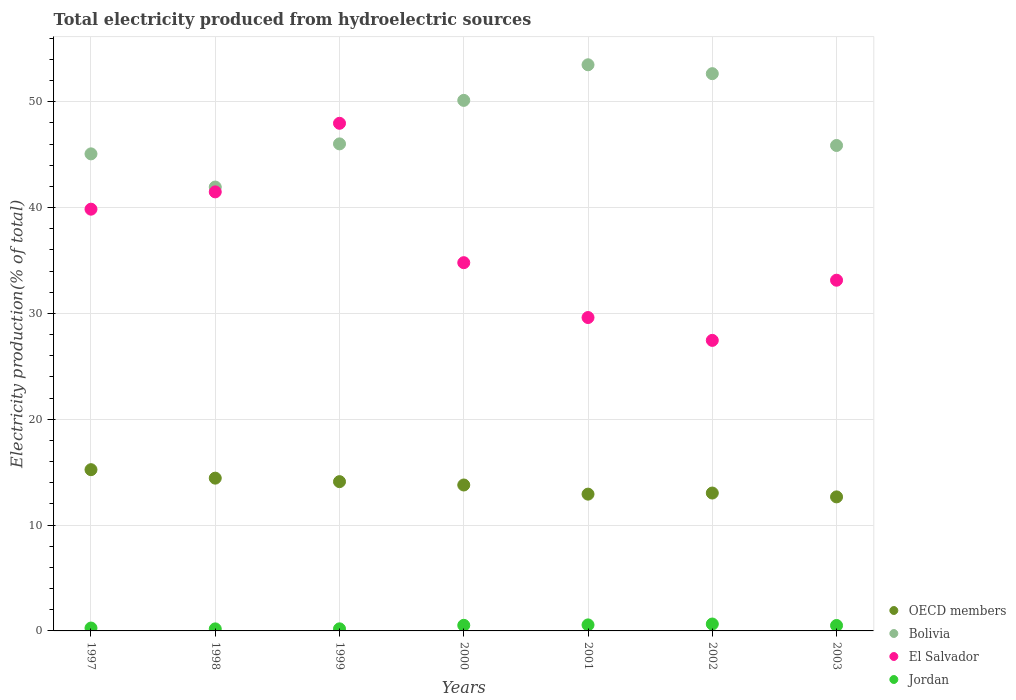Is the number of dotlines equal to the number of legend labels?
Your answer should be compact. Yes. What is the total electricity produced in OECD members in 2001?
Offer a very short reply. 12.92. Across all years, what is the maximum total electricity produced in Jordan?
Provide a short and direct response. 0.65. Across all years, what is the minimum total electricity produced in Jordan?
Keep it short and to the point. 0.19. In which year was the total electricity produced in Jordan maximum?
Keep it short and to the point. 2002. In which year was the total electricity produced in Jordan minimum?
Provide a short and direct response. 1998. What is the total total electricity produced in Bolivia in the graph?
Your answer should be very brief. 335.18. What is the difference between the total electricity produced in OECD members in 2000 and that in 2002?
Offer a terse response. 0.76. What is the difference between the total electricity produced in Jordan in 2003 and the total electricity produced in Bolivia in 2000?
Your response must be concise. -49.62. What is the average total electricity produced in Jordan per year?
Offer a very short reply. 0.42. In the year 1999, what is the difference between the total electricity produced in Jordan and total electricity produced in OECD members?
Keep it short and to the point. -13.91. What is the ratio of the total electricity produced in Jordan in 2001 to that in 2003?
Your response must be concise. 1.11. What is the difference between the highest and the second highest total electricity produced in OECD members?
Provide a short and direct response. 0.8. What is the difference between the highest and the lowest total electricity produced in Jordan?
Keep it short and to the point. 0.46. In how many years, is the total electricity produced in OECD members greater than the average total electricity produced in OECD members taken over all years?
Offer a very short reply. 4. Is the sum of the total electricity produced in Jordan in 1999 and 2001 greater than the maximum total electricity produced in Bolivia across all years?
Your answer should be very brief. No. Is it the case that in every year, the sum of the total electricity produced in Bolivia and total electricity produced in Jordan  is greater than the sum of total electricity produced in El Salvador and total electricity produced in OECD members?
Your answer should be compact. Yes. Does the total electricity produced in El Salvador monotonically increase over the years?
Make the answer very short. No. Is the total electricity produced in Bolivia strictly less than the total electricity produced in El Salvador over the years?
Provide a short and direct response. No. How many dotlines are there?
Your answer should be compact. 4. What is the difference between two consecutive major ticks on the Y-axis?
Keep it short and to the point. 10. Are the values on the major ticks of Y-axis written in scientific E-notation?
Provide a short and direct response. No. Does the graph contain any zero values?
Ensure brevity in your answer.  No. Where does the legend appear in the graph?
Make the answer very short. Bottom right. How many legend labels are there?
Offer a terse response. 4. How are the legend labels stacked?
Your answer should be very brief. Vertical. What is the title of the graph?
Your response must be concise. Total electricity produced from hydroelectric sources. Does "Palau" appear as one of the legend labels in the graph?
Provide a succinct answer. No. What is the label or title of the X-axis?
Give a very brief answer. Years. What is the label or title of the Y-axis?
Keep it short and to the point. Electricity production(% of total). What is the Electricity production(% of total) of OECD members in 1997?
Give a very brief answer. 15.24. What is the Electricity production(% of total) of Bolivia in 1997?
Give a very brief answer. 45.07. What is the Electricity production(% of total) in El Salvador in 1997?
Your response must be concise. 39.85. What is the Electricity production(% of total) in Jordan in 1997?
Your answer should be compact. 0.27. What is the Electricity production(% of total) in OECD members in 1998?
Offer a terse response. 14.44. What is the Electricity production(% of total) in Bolivia in 1998?
Offer a terse response. 41.94. What is the Electricity production(% of total) in El Salvador in 1998?
Ensure brevity in your answer.  41.48. What is the Electricity production(% of total) of Jordan in 1998?
Your answer should be compact. 0.19. What is the Electricity production(% of total) of OECD members in 1999?
Ensure brevity in your answer.  14.1. What is the Electricity production(% of total) of Bolivia in 1999?
Ensure brevity in your answer.  46.02. What is the Electricity production(% of total) of El Salvador in 1999?
Offer a very short reply. 47.96. What is the Electricity production(% of total) of Jordan in 1999?
Your answer should be compact. 0.2. What is the Electricity production(% of total) of OECD members in 2000?
Offer a very short reply. 13.79. What is the Electricity production(% of total) in Bolivia in 2000?
Provide a short and direct response. 50.13. What is the Electricity production(% of total) of El Salvador in 2000?
Offer a very short reply. 34.79. What is the Electricity production(% of total) of Jordan in 2000?
Keep it short and to the point. 0.53. What is the Electricity production(% of total) of OECD members in 2001?
Keep it short and to the point. 12.92. What is the Electricity production(% of total) in Bolivia in 2001?
Your answer should be compact. 53.49. What is the Electricity production(% of total) of El Salvador in 2001?
Provide a short and direct response. 29.61. What is the Electricity production(% of total) of Jordan in 2001?
Provide a succinct answer. 0.57. What is the Electricity production(% of total) of OECD members in 2002?
Ensure brevity in your answer.  13.03. What is the Electricity production(% of total) in Bolivia in 2002?
Provide a succinct answer. 52.65. What is the Electricity production(% of total) of El Salvador in 2002?
Your answer should be very brief. 27.45. What is the Electricity production(% of total) of Jordan in 2002?
Ensure brevity in your answer.  0.65. What is the Electricity production(% of total) of OECD members in 2003?
Your response must be concise. 12.66. What is the Electricity production(% of total) of Bolivia in 2003?
Ensure brevity in your answer.  45.87. What is the Electricity production(% of total) of El Salvador in 2003?
Keep it short and to the point. 33.14. What is the Electricity production(% of total) of Jordan in 2003?
Provide a short and direct response. 0.51. Across all years, what is the maximum Electricity production(% of total) in OECD members?
Make the answer very short. 15.24. Across all years, what is the maximum Electricity production(% of total) in Bolivia?
Give a very brief answer. 53.49. Across all years, what is the maximum Electricity production(% of total) in El Salvador?
Offer a terse response. 47.96. Across all years, what is the maximum Electricity production(% of total) of Jordan?
Give a very brief answer. 0.65. Across all years, what is the minimum Electricity production(% of total) in OECD members?
Provide a short and direct response. 12.66. Across all years, what is the minimum Electricity production(% of total) of Bolivia?
Your response must be concise. 41.94. Across all years, what is the minimum Electricity production(% of total) in El Salvador?
Your answer should be compact. 27.45. Across all years, what is the minimum Electricity production(% of total) in Jordan?
Offer a terse response. 0.19. What is the total Electricity production(% of total) of OECD members in the graph?
Provide a short and direct response. 96.18. What is the total Electricity production(% of total) of Bolivia in the graph?
Give a very brief answer. 335.18. What is the total Electricity production(% of total) of El Salvador in the graph?
Give a very brief answer. 254.29. What is the total Electricity production(% of total) of Jordan in the graph?
Offer a terse response. 2.92. What is the difference between the Electricity production(% of total) of OECD members in 1997 and that in 1998?
Your answer should be compact. 0.8. What is the difference between the Electricity production(% of total) of Bolivia in 1997 and that in 1998?
Your answer should be very brief. 3.13. What is the difference between the Electricity production(% of total) of El Salvador in 1997 and that in 1998?
Your response must be concise. -1.63. What is the difference between the Electricity production(% of total) in Jordan in 1997 and that in 1998?
Provide a succinct answer. 0.08. What is the difference between the Electricity production(% of total) of OECD members in 1997 and that in 1999?
Provide a succinct answer. 1.13. What is the difference between the Electricity production(% of total) in Bolivia in 1997 and that in 1999?
Your answer should be compact. -0.94. What is the difference between the Electricity production(% of total) of El Salvador in 1997 and that in 1999?
Provide a short and direct response. -8.11. What is the difference between the Electricity production(% of total) in Jordan in 1997 and that in 1999?
Give a very brief answer. 0.07. What is the difference between the Electricity production(% of total) of OECD members in 1997 and that in 2000?
Your answer should be very brief. 1.45. What is the difference between the Electricity production(% of total) in Bolivia in 1997 and that in 2000?
Provide a succinct answer. -5.05. What is the difference between the Electricity production(% of total) of El Salvador in 1997 and that in 2000?
Make the answer very short. 5.06. What is the difference between the Electricity production(% of total) in Jordan in 1997 and that in 2000?
Offer a terse response. -0.26. What is the difference between the Electricity production(% of total) in OECD members in 1997 and that in 2001?
Your answer should be compact. 2.31. What is the difference between the Electricity production(% of total) in Bolivia in 1997 and that in 2001?
Your answer should be compact. -8.42. What is the difference between the Electricity production(% of total) of El Salvador in 1997 and that in 2001?
Ensure brevity in your answer.  10.24. What is the difference between the Electricity production(% of total) in Jordan in 1997 and that in 2001?
Provide a short and direct response. -0.3. What is the difference between the Electricity production(% of total) of OECD members in 1997 and that in 2002?
Ensure brevity in your answer.  2.21. What is the difference between the Electricity production(% of total) in Bolivia in 1997 and that in 2002?
Make the answer very short. -7.58. What is the difference between the Electricity production(% of total) of El Salvador in 1997 and that in 2002?
Provide a short and direct response. 12.4. What is the difference between the Electricity production(% of total) of Jordan in 1997 and that in 2002?
Keep it short and to the point. -0.38. What is the difference between the Electricity production(% of total) of OECD members in 1997 and that in 2003?
Offer a very short reply. 2.57. What is the difference between the Electricity production(% of total) in Bolivia in 1997 and that in 2003?
Your answer should be very brief. -0.79. What is the difference between the Electricity production(% of total) of El Salvador in 1997 and that in 2003?
Provide a short and direct response. 6.71. What is the difference between the Electricity production(% of total) in Jordan in 1997 and that in 2003?
Your answer should be very brief. -0.24. What is the difference between the Electricity production(% of total) in OECD members in 1998 and that in 1999?
Your response must be concise. 0.33. What is the difference between the Electricity production(% of total) of Bolivia in 1998 and that in 1999?
Provide a short and direct response. -4.08. What is the difference between the Electricity production(% of total) of El Salvador in 1998 and that in 1999?
Provide a succinct answer. -6.48. What is the difference between the Electricity production(% of total) in Jordan in 1998 and that in 1999?
Offer a very short reply. -0.01. What is the difference between the Electricity production(% of total) of OECD members in 1998 and that in 2000?
Your answer should be very brief. 0.65. What is the difference between the Electricity production(% of total) of Bolivia in 1998 and that in 2000?
Your answer should be compact. -8.19. What is the difference between the Electricity production(% of total) in El Salvador in 1998 and that in 2000?
Your answer should be very brief. 6.69. What is the difference between the Electricity production(% of total) of Jordan in 1998 and that in 2000?
Your answer should be very brief. -0.34. What is the difference between the Electricity production(% of total) in OECD members in 1998 and that in 2001?
Ensure brevity in your answer.  1.51. What is the difference between the Electricity production(% of total) in Bolivia in 1998 and that in 2001?
Your answer should be compact. -11.55. What is the difference between the Electricity production(% of total) in El Salvador in 1998 and that in 2001?
Keep it short and to the point. 11.87. What is the difference between the Electricity production(% of total) in Jordan in 1998 and that in 2001?
Provide a short and direct response. -0.38. What is the difference between the Electricity production(% of total) of OECD members in 1998 and that in 2002?
Provide a succinct answer. 1.41. What is the difference between the Electricity production(% of total) of Bolivia in 1998 and that in 2002?
Your response must be concise. -10.71. What is the difference between the Electricity production(% of total) of El Salvador in 1998 and that in 2002?
Ensure brevity in your answer.  14.03. What is the difference between the Electricity production(% of total) in Jordan in 1998 and that in 2002?
Provide a succinct answer. -0.46. What is the difference between the Electricity production(% of total) of OECD members in 1998 and that in 2003?
Provide a succinct answer. 1.77. What is the difference between the Electricity production(% of total) in Bolivia in 1998 and that in 2003?
Give a very brief answer. -3.93. What is the difference between the Electricity production(% of total) of El Salvador in 1998 and that in 2003?
Your answer should be very brief. 8.35. What is the difference between the Electricity production(% of total) of Jordan in 1998 and that in 2003?
Ensure brevity in your answer.  -0.32. What is the difference between the Electricity production(% of total) of OECD members in 1999 and that in 2000?
Offer a very short reply. 0.32. What is the difference between the Electricity production(% of total) of Bolivia in 1999 and that in 2000?
Offer a terse response. -4.11. What is the difference between the Electricity production(% of total) of El Salvador in 1999 and that in 2000?
Provide a succinct answer. 13.17. What is the difference between the Electricity production(% of total) of Jordan in 1999 and that in 2000?
Make the answer very short. -0.33. What is the difference between the Electricity production(% of total) of OECD members in 1999 and that in 2001?
Your response must be concise. 1.18. What is the difference between the Electricity production(% of total) of Bolivia in 1999 and that in 2001?
Offer a very short reply. -7.47. What is the difference between the Electricity production(% of total) in El Salvador in 1999 and that in 2001?
Your response must be concise. 18.35. What is the difference between the Electricity production(% of total) in Jordan in 1999 and that in 2001?
Provide a succinct answer. -0.37. What is the difference between the Electricity production(% of total) in OECD members in 1999 and that in 2002?
Provide a short and direct response. 1.08. What is the difference between the Electricity production(% of total) in Bolivia in 1999 and that in 2002?
Offer a very short reply. -6.63. What is the difference between the Electricity production(% of total) in El Salvador in 1999 and that in 2002?
Offer a terse response. 20.51. What is the difference between the Electricity production(% of total) in Jordan in 1999 and that in 2002?
Your answer should be very brief. -0.45. What is the difference between the Electricity production(% of total) in OECD members in 1999 and that in 2003?
Your response must be concise. 1.44. What is the difference between the Electricity production(% of total) in Bolivia in 1999 and that in 2003?
Offer a terse response. 0.15. What is the difference between the Electricity production(% of total) in El Salvador in 1999 and that in 2003?
Provide a succinct answer. 14.83. What is the difference between the Electricity production(% of total) in Jordan in 1999 and that in 2003?
Keep it short and to the point. -0.32. What is the difference between the Electricity production(% of total) of OECD members in 2000 and that in 2001?
Ensure brevity in your answer.  0.86. What is the difference between the Electricity production(% of total) in Bolivia in 2000 and that in 2001?
Offer a terse response. -3.36. What is the difference between the Electricity production(% of total) of El Salvador in 2000 and that in 2001?
Your answer should be very brief. 5.18. What is the difference between the Electricity production(% of total) in Jordan in 2000 and that in 2001?
Provide a short and direct response. -0.04. What is the difference between the Electricity production(% of total) in OECD members in 2000 and that in 2002?
Keep it short and to the point. 0.76. What is the difference between the Electricity production(% of total) of Bolivia in 2000 and that in 2002?
Make the answer very short. -2.52. What is the difference between the Electricity production(% of total) of El Salvador in 2000 and that in 2002?
Your answer should be very brief. 7.34. What is the difference between the Electricity production(% of total) in Jordan in 2000 and that in 2002?
Offer a very short reply. -0.12. What is the difference between the Electricity production(% of total) in OECD members in 2000 and that in 2003?
Keep it short and to the point. 1.12. What is the difference between the Electricity production(% of total) in Bolivia in 2000 and that in 2003?
Your answer should be very brief. 4.26. What is the difference between the Electricity production(% of total) of El Salvador in 2000 and that in 2003?
Ensure brevity in your answer.  1.66. What is the difference between the Electricity production(% of total) in Jordan in 2000 and that in 2003?
Your answer should be compact. 0.02. What is the difference between the Electricity production(% of total) of OECD members in 2001 and that in 2002?
Offer a very short reply. -0.1. What is the difference between the Electricity production(% of total) in Bolivia in 2001 and that in 2002?
Keep it short and to the point. 0.84. What is the difference between the Electricity production(% of total) of El Salvador in 2001 and that in 2002?
Make the answer very short. 2.16. What is the difference between the Electricity production(% of total) of Jordan in 2001 and that in 2002?
Provide a succinct answer. -0.08. What is the difference between the Electricity production(% of total) of OECD members in 2001 and that in 2003?
Offer a very short reply. 0.26. What is the difference between the Electricity production(% of total) of Bolivia in 2001 and that in 2003?
Your answer should be very brief. 7.62. What is the difference between the Electricity production(% of total) of El Salvador in 2001 and that in 2003?
Keep it short and to the point. -3.53. What is the difference between the Electricity production(% of total) of Jordan in 2001 and that in 2003?
Offer a very short reply. 0.06. What is the difference between the Electricity production(% of total) of OECD members in 2002 and that in 2003?
Your answer should be very brief. 0.36. What is the difference between the Electricity production(% of total) of Bolivia in 2002 and that in 2003?
Provide a succinct answer. 6.79. What is the difference between the Electricity production(% of total) in El Salvador in 2002 and that in 2003?
Your response must be concise. -5.68. What is the difference between the Electricity production(% of total) in Jordan in 2002 and that in 2003?
Your answer should be compact. 0.14. What is the difference between the Electricity production(% of total) of OECD members in 1997 and the Electricity production(% of total) of Bolivia in 1998?
Ensure brevity in your answer.  -26.7. What is the difference between the Electricity production(% of total) of OECD members in 1997 and the Electricity production(% of total) of El Salvador in 1998?
Ensure brevity in your answer.  -26.25. What is the difference between the Electricity production(% of total) of OECD members in 1997 and the Electricity production(% of total) of Jordan in 1998?
Offer a very short reply. 15.04. What is the difference between the Electricity production(% of total) of Bolivia in 1997 and the Electricity production(% of total) of El Salvador in 1998?
Give a very brief answer. 3.59. What is the difference between the Electricity production(% of total) in Bolivia in 1997 and the Electricity production(% of total) in Jordan in 1998?
Your answer should be very brief. 44.88. What is the difference between the Electricity production(% of total) in El Salvador in 1997 and the Electricity production(% of total) in Jordan in 1998?
Your answer should be compact. 39.66. What is the difference between the Electricity production(% of total) of OECD members in 1997 and the Electricity production(% of total) of Bolivia in 1999?
Provide a short and direct response. -30.78. What is the difference between the Electricity production(% of total) of OECD members in 1997 and the Electricity production(% of total) of El Salvador in 1999?
Your answer should be very brief. -32.73. What is the difference between the Electricity production(% of total) of OECD members in 1997 and the Electricity production(% of total) of Jordan in 1999?
Keep it short and to the point. 15.04. What is the difference between the Electricity production(% of total) in Bolivia in 1997 and the Electricity production(% of total) in El Salvador in 1999?
Provide a succinct answer. -2.89. What is the difference between the Electricity production(% of total) in Bolivia in 1997 and the Electricity production(% of total) in Jordan in 1999?
Ensure brevity in your answer.  44.88. What is the difference between the Electricity production(% of total) in El Salvador in 1997 and the Electricity production(% of total) in Jordan in 1999?
Ensure brevity in your answer.  39.65. What is the difference between the Electricity production(% of total) of OECD members in 1997 and the Electricity production(% of total) of Bolivia in 2000?
Ensure brevity in your answer.  -34.89. What is the difference between the Electricity production(% of total) in OECD members in 1997 and the Electricity production(% of total) in El Salvador in 2000?
Your response must be concise. -19.56. What is the difference between the Electricity production(% of total) in OECD members in 1997 and the Electricity production(% of total) in Jordan in 2000?
Offer a terse response. 14.71. What is the difference between the Electricity production(% of total) in Bolivia in 1997 and the Electricity production(% of total) in El Salvador in 2000?
Provide a succinct answer. 10.28. What is the difference between the Electricity production(% of total) in Bolivia in 1997 and the Electricity production(% of total) in Jordan in 2000?
Offer a terse response. 44.55. What is the difference between the Electricity production(% of total) of El Salvador in 1997 and the Electricity production(% of total) of Jordan in 2000?
Your answer should be compact. 39.32. What is the difference between the Electricity production(% of total) in OECD members in 1997 and the Electricity production(% of total) in Bolivia in 2001?
Offer a very short reply. -38.26. What is the difference between the Electricity production(% of total) in OECD members in 1997 and the Electricity production(% of total) in El Salvador in 2001?
Offer a terse response. -14.38. What is the difference between the Electricity production(% of total) of OECD members in 1997 and the Electricity production(% of total) of Jordan in 2001?
Offer a terse response. 14.67. What is the difference between the Electricity production(% of total) in Bolivia in 1997 and the Electricity production(% of total) in El Salvador in 2001?
Your answer should be compact. 15.46. What is the difference between the Electricity production(% of total) in Bolivia in 1997 and the Electricity production(% of total) in Jordan in 2001?
Provide a succinct answer. 44.51. What is the difference between the Electricity production(% of total) in El Salvador in 1997 and the Electricity production(% of total) in Jordan in 2001?
Your answer should be very brief. 39.28. What is the difference between the Electricity production(% of total) in OECD members in 1997 and the Electricity production(% of total) in Bolivia in 2002?
Offer a terse response. -37.42. What is the difference between the Electricity production(% of total) of OECD members in 1997 and the Electricity production(% of total) of El Salvador in 2002?
Provide a succinct answer. -12.22. What is the difference between the Electricity production(% of total) in OECD members in 1997 and the Electricity production(% of total) in Jordan in 2002?
Keep it short and to the point. 14.58. What is the difference between the Electricity production(% of total) in Bolivia in 1997 and the Electricity production(% of total) in El Salvador in 2002?
Ensure brevity in your answer.  17.62. What is the difference between the Electricity production(% of total) in Bolivia in 1997 and the Electricity production(% of total) in Jordan in 2002?
Offer a very short reply. 44.42. What is the difference between the Electricity production(% of total) in El Salvador in 1997 and the Electricity production(% of total) in Jordan in 2002?
Your answer should be very brief. 39.2. What is the difference between the Electricity production(% of total) in OECD members in 1997 and the Electricity production(% of total) in Bolivia in 2003?
Provide a succinct answer. -30.63. What is the difference between the Electricity production(% of total) of OECD members in 1997 and the Electricity production(% of total) of El Salvador in 2003?
Your answer should be very brief. -17.9. What is the difference between the Electricity production(% of total) in OECD members in 1997 and the Electricity production(% of total) in Jordan in 2003?
Give a very brief answer. 14.72. What is the difference between the Electricity production(% of total) in Bolivia in 1997 and the Electricity production(% of total) in El Salvador in 2003?
Provide a short and direct response. 11.94. What is the difference between the Electricity production(% of total) of Bolivia in 1997 and the Electricity production(% of total) of Jordan in 2003?
Give a very brief answer. 44.56. What is the difference between the Electricity production(% of total) in El Salvador in 1997 and the Electricity production(% of total) in Jordan in 2003?
Provide a short and direct response. 39.34. What is the difference between the Electricity production(% of total) of OECD members in 1998 and the Electricity production(% of total) of Bolivia in 1999?
Your response must be concise. -31.58. What is the difference between the Electricity production(% of total) in OECD members in 1998 and the Electricity production(% of total) in El Salvador in 1999?
Provide a short and direct response. -33.53. What is the difference between the Electricity production(% of total) of OECD members in 1998 and the Electricity production(% of total) of Jordan in 1999?
Offer a very short reply. 14.24. What is the difference between the Electricity production(% of total) of Bolivia in 1998 and the Electricity production(% of total) of El Salvador in 1999?
Provide a succinct answer. -6.02. What is the difference between the Electricity production(% of total) of Bolivia in 1998 and the Electricity production(% of total) of Jordan in 1999?
Provide a short and direct response. 41.74. What is the difference between the Electricity production(% of total) of El Salvador in 1998 and the Electricity production(% of total) of Jordan in 1999?
Provide a succinct answer. 41.29. What is the difference between the Electricity production(% of total) in OECD members in 1998 and the Electricity production(% of total) in Bolivia in 2000?
Offer a very short reply. -35.69. What is the difference between the Electricity production(% of total) in OECD members in 1998 and the Electricity production(% of total) in El Salvador in 2000?
Offer a terse response. -20.36. What is the difference between the Electricity production(% of total) of OECD members in 1998 and the Electricity production(% of total) of Jordan in 2000?
Your answer should be compact. 13.91. What is the difference between the Electricity production(% of total) of Bolivia in 1998 and the Electricity production(% of total) of El Salvador in 2000?
Offer a very short reply. 7.15. What is the difference between the Electricity production(% of total) of Bolivia in 1998 and the Electricity production(% of total) of Jordan in 2000?
Keep it short and to the point. 41.41. What is the difference between the Electricity production(% of total) of El Salvador in 1998 and the Electricity production(% of total) of Jordan in 2000?
Provide a short and direct response. 40.95. What is the difference between the Electricity production(% of total) in OECD members in 1998 and the Electricity production(% of total) in Bolivia in 2001?
Give a very brief answer. -39.06. What is the difference between the Electricity production(% of total) in OECD members in 1998 and the Electricity production(% of total) in El Salvador in 2001?
Offer a very short reply. -15.18. What is the difference between the Electricity production(% of total) in OECD members in 1998 and the Electricity production(% of total) in Jordan in 2001?
Your response must be concise. 13.87. What is the difference between the Electricity production(% of total) of Bolivia in 1998 and the Electricity production(% of total) of El Salvador in 2001?
Provide a succinct answer. 12.33. What is the difference between the Electricity production(% of total) of Bolivia in 1998 and the Electricity production(% of total) of Jordan in 2001?
Provide a succinct answer. 41.37. What is the difference between the Electricity production(% of total) of El Salvador in 1998 and the Electricity production(% of total) of Jordan in 2001?
Provide a short and direct response. 40.91. What is the difference between the Electricity production(% of total) in OECD members in 1998 and the Electricity production(% of total) in Bolivia in 2002?
Ensure brevity in your answer.  -38.22. What is the difference between the Electricity production(% of total) in OECD members in 1998 and the Electricity production(% of total) in El Salvador in 2002?
Your response must be concise. -13.02. What is the difference between the Electricity production(% of total) in OECD members in 1998 and the Electricity production(% of total) in Jordan in 2002?
Offer a very short reply. 13.78. What is the difference between the Electricity production(% of total) in Bolivia in 1998 and the Electricity production(% of total) in El Salvador in 2002?
Offer a terse response. 14.49. What is the difference between the Electricity production(% of total) of Bolivia in 1998 and the Electricity production(% of total) of Jordan in 2002?
Offer a very short reply. 41.29. What is the difference between the Electricity production(% of total) in El Salvador in 1998 and the Electricity production(% of total) in Jordan in 2002?
Offer a very short reply. 40.83. What is the difference between the Electricity production(% of total) in OECD members in 1998 and the Electricity production(% of total) in Bolivia in 2003?
Your answer should be compact. -31.43. What is the difference between the Electricity production(% of total) in OECD members in 1998 and the Electricity production(% of total) in El Salvador in 2003?
Offer a terse response. -18.7. What is the difference between the Electricity production(% of total) in OECD members in 1998 and the Electricity production(% of total) in Jordan in 2003?
Ensure brevity in your answer.  13.92. What is the difference between the Electricity production(% of total) of Bolivia in 1998 and the Electricity production(% of total) of El Salvador in 2003?
Offer a terse response. 8.8. What is the difference between the Electricity production(% of total) of Bolivia in 1998 and the Electricity production(% of total) of Jordan in 2003?
Offer a terse response. 41.43. What is the difference between the Electricity production(% of total) in El Salvador in 1998 and the Electricity production(% of total) in Jordan in 2003?
Offer a very short reply. 40.97. What is the difference between the Electricity production(% of total) in OECD members in 1999 and the Electricity production(% of total) in Bolivia in 2000?
Your response must be concise. -36.02. What is the difference between the Electricity production(% of total) of OECD members in 1999 and the Electricity production(% of total) of El Salvador in 2000?
Make the answer very short. -20.69. What is the difference between the Electricity production(% of total) of OECD members in 1999 and the Electricity production(% of total) of Jordan in 2000?
Your response must be concise. 13.58. What is the difference between the Electricity production(% of total) of Bolivia in 1999 and the Electricity production(% of total) of El Salvador in 2000?
Offer a very short reply. 11.22. What is the difference between the Electricity production(% of total) of Bolivia in 1999 and the Electricity production(% of total) of Jordan in 2000?
Ensure brevity in your answer.  45.49. What is the difference between the Electricity production(% of total) in El Salvador in 1999 and the Electricity production(% of total) in Jordan in 2000?
Offer a very short reply. 47.44. What is the difference between the Electricity production(% of total) of OECD members in 1999 and the Electricity production(% of total) of Bolivia in 2001?
Your answer should be compact. -39.39. What is the difference between the Electricity production(% of total) in OECD members in 1999 and the Electricity production(% of total) in El Salvador in 2001?
Provide a short and direct response. -15.51. What is the difference between the Electricity production(% of total) in OECD members in 1999 and the Electricity production(% of total) in Jordan in 2001?
Your response must be concise. 13.53. What is the difference between the Electricity production(% of total) in Bolivia in 1999 and the Electricity production(% of total) in El Salvador in 2001?
Your answer should be compact. 16.41. What is the difference between the Electricity production(% of total) of Bolivia in 1999 and the Electricity production(% of total) of Jordan in 2001?
Give a very brief answer. 45.45. What is the difference between the Electricity production(% of total) of El Salvador in 1999 and the Electricity production(% of total) of Jordan in 2001?
Provide a short and direct response. 47.39. What is the difference between the Electricity production(% of total) of OECD members in 1999 and the Electricity production(% of total) of Bolivia in 2002?
Ensure brevity in your answer.  -38.55. What is the difference between the Electricity production(% of total) of OECD members in 1999 and the Electricity production(% of total) of El Salvador in 2002?
Offer a very short reply. -13.35. What is the difference between the Electricity production(% of total) in OECD members in 1999 and the Electricity production(% of total) in Jordan in 2002?
Your answer should be compact. 13.45. What is the difference between the Electricity production(% of total) in Bolivia in 1999 and the Electricity production(% of total) in El Salvador in 2002?
Provide a short and direct response. 18.57. What is the difference between the Electricity production(% of total) of Bolivia in 1999 and the Electricity production(% of total) of Jordan in 2002?
Ensure brevity in your answer.  45.37. What is the difference between the Electricity production(% of total) of El Salvador in 1999 and the Electricity production(% of total) of Jordan in 2002?
Give a very brief answer. 47.31. What is the difference between the Electricity production(% of total) of OECD members in 1999 and the Electricity production(% of total) of Bolivia in 2003?
Offer a terse response. -31.76. What is the difference between the Electricity production(% of total) in OECD members in 1999 and the Electricity production(% of total) in El Salvador in 2003?
Ensure brevity in your answer.  -19.03. What is the difference between the Electricity production(% of total) of OECD members in 1999 and the Electricity production(% of total) of Jordan in 2003?
Your response must be concise. 13.59. What is the difference between the Electricity production(% of total) of Bolivia in 1999 and the Electricity production(% of total) of El Salvador in 2003?
Your response must be concise. 12.88. What is the difference between the Electricity production(% of total) of Bolivia in 1999 and the Electricity production(% of total) of Jordan in 2003?
Make the answer very short. 45.51. What is the difference between the Electricity production(% of total) of El Salvador in 1999 and the Electricity production(% of total) of Jordan in 2003?
Keep it short and to the point. 47.45. What is the difference between the Electricity production(% of total) of OECD members in 2000 and the Electricity production(% of total) of Bolivia in 2001?
Keep it short and to the point. -39.7. What is the difference between the Electricity production(% of total) of OECD members in 2000 and the Electricity production(% of total) of El Salvador in 2001?
Give a very brief answer. -15.82. What is the difference between the Electricity production(% of total) of OECD members in 2000 and the Electricity production(% of total) of Jordan in 2001?
Your answer should be compact. 13.22. What is the difference between the Electricity production(% of total) in Bolivia in 2000 and the Electricity production(% of total) in El Salvador in 2001?
Ensure brevity in your answer.  20.52. What is the difference between the Electricity production(% of total) in Bolivia in 2000 and the Electricity production(% of total) in Jordan in 2001?
Offer a very short reply. 49.56. What is the difference between the Electricity production(% of total) of El Salvador in 2000 and the Electricity production(% of total) of Jordan in 2001?
Make the answer very short. 34.22. What is the difference between the Electricity production(% of total) in OECD members in 2000 and the Electricity production(% of total) in Bolivia in 2002?
Your answer should be compact. -38.86. What is the difference between the Electricity production(% of total) in OECD members in 2000 and the Electricity production(% of total) in El Salvador in 2002?
Ensure brevity in your answer.  -13.66. What is the difference between the Electricity production(% of total) in OECD members in 2000 and the Electricity production(% of total) in Jordan in 2002?
Provide a succinct answer. 13.14. What is the difference between the Electricity production(% of total) of Bolivia in 2000 and the Electricity production(% of total) of El Salvador in 2002?
Give a very brief answer. 22.68. What is the difference between the Electricity production(% of total) of Bolivia in 2000 and the Electricity production(% of total) of Jordan in 2002?
Your response must be concise. 49.48. What is the difference between the Electricity production(% of total) of El Salvador in 2000 and the Electricity production(% of total) of Jordan in 2002?
Offer a terse response. 34.14. What is the difference between the Electricity production(% of total) of OECD members in 2000 and the Electricity production(% of total) of Bolivia in 2003?
Your answer should be very brief. -32.08. What is the difference between the Electricity production(% of total) of OECD members in 2000 and the Electricity production(% of total) of El Salvador in 2003?
Ensure brevity in your answer.  -19.35. What is the difference between the Electricity production(% of total) of OECD members in 2000 and the Electricity production(% of total) of Jordan in 2003?
Provide a succinct answer. 13.28. What is the difference between the Electricity production(% of total) in Bolivia in 2000 and the Electricity production(% of total) in El Salvador in 2003?
Make the answer very short. 16.99. What is the difference between the Electricity production(% of total) in Bolivia in 2000 and the Electricity production(% of total) in Jordan in 2003?
Your answer should be compact. 49.62. What is the difference between the Electricity production(% of total) in El Salvador in 2000 and the Electricity production(% of total) in Jordan in 2003?
Ensure brevity in your answer.  34.28. What is the difference between the Electricity production(% of total) of OECD members in 2001 and the Electricity production(% of total) of Bolivia in 2002?
Ensure brevity in your answer.  -39.73. What is the difference between the Electricity production(% of total) in OECD members in 2001 and the Electricity production(% of total) in El Salvador in 2002?
Provide a succinct answer. -14.53. What is the difference between the Electricity production(% of total) in OECD members in 2001 and the Electricity production(% of total) in Jordan in 2002?
Ensure brevity in your answer.  12.27. What is the difference between the Electricity production(% of total) in Bolivia in 2001 and the Electricity production(% of total) in El Salvador in 2002?
Give a very brief answer. 26.04. What is the difference between the Electricity production(% of total) of Bolivia in 2001 and the Electricity production(% of total) of Jordan in 2002?
Offer a very short reply. 52.84. What is the difference between the Electricity production(% of total) of El Salvador in 2001 and the Electricity production(% of total) of Jordan in 2002?
Offer a very short reply. 28.96. What is the difference between the Electricity production(% of total) of OECD members in 2001 and the Electricity production(% of total) of Bolivia in 2003?
Provide a short and direct response. -32.94. What is the difference between the Electricity production(% of total) of OECD members in 2001 and the Electricity production(% of total) of El Salvador in 2003?
Your answer should be very brief. -20.21. What is the difference between the Electricity production(% of total) of OECD members in 2001 and the Electricity production(% of total) of Jordan in 2003?
Provide a short and direct response. 12.41. What is the difference between the Electricity production(% of total) of Bolivia in 2001 and the Electricity production(% of total) of El Salvador in 2003?
Your answer should be compact. 20.36. What is the difference between the Electricity production(% of total) of Bolivia in 2001 and the Electricity production(% of total) of Jordan in 2003?
Your response must be concise. 52.98. What is the difference between the Electricity production(% of total) of El Salvador in 2001 and the Electricity production(% of total) of Jordan in 2003?
Your answer should be very brief. 29.1. What is the difference between the Electricity production(% of total) in OECD members in 2002 and the Electricity production(% of total) in Bolivia in 2003?
Your response must be concise. -32.84. What is the difference between the Electricity production(% of total) of OECD members in 2002 and the Electricity production(% of total) of El Salvador in 2003?
Ensure brevity in your answer.  -20.11. What is the difference between the Electricity production(% of total) in OECD members in 2002 and the Electricity production(% of total) in Jordan in 2003?
Your answer should be compact. 12.52. What is the difference between the Electricity production(% of total) in Bolivia in 2002 and the Electricity production(% of total) in El Salvador in 2003?
Your answer should be compact. 19.52. What is the difference between the Electricity production(% of total) in Bolivia in 2002 and the Electricity production(% of total) in Jordan in 2003?
Offer a very short reply. 52.14. What is the difference between the Electricity production(% of total) of El Salvador in 2002 and the Electricity production(% of total) of Jordan in 2003?
Provide a succinct answer. 26.94. What is the average Electricity production(% of total) in OECD members per year?
Your answer should be compact. 13.74. What is the average Electricity production(% of total) of Bolivia per year?
Your answer should be compact. 47.88. What is the average Electricity production(% of total) in El Salvador per year?
Ensure brevity in your answer.  36.33. What is the average Electricity production(% of total) of Jordan per year?
Provide a short and direct response. 0.42. In the year 1997, what is the difference between the Electricity production(% of total) in OECD members and Electricity production(% of total) in Bolivia?
Give a very brief answer. -29.84. In the year 1997, what is the difference between the Electricity production(% of total) in OECD members and Electricity production(% of total) in El Salvador?
Give a very brief answer. -24.61. In the year 1997, what is the difference between the Electricity production(% of total) in OECD members and Electricity production(% of total) in Jordan?
Provide a short and direct response. 14.96. In the year 1997, what is the difference between the Electricity production(% of total) in Bolivia and Electricity production(% of total) in El Salvador?
Provide a short and direct response. 5.23. In the year 1997, what is the difference between the Electricity production(% of total) of Bolivia and Electricity production(% of total) of Jordan?
Your answer should be very brief. 44.8. In the year 1997, what is the difference between the Electricity production(% of total) of El Salvador and Electricity production(% of total) of Jordan?
Your answer should be very brief. 39.58. In the year 1998, what is the difference between the Electricity production(% of total) of OECD members and Electricity production(% of total) of Bolivia?
Make the answer very short. -27.51. In the year 1998, what is the difference between the Electricity production(% of total) of OECD members and Electricity production(% of total) of El Salvador?
Your answer should be compact. -27.05. In the year 1998, what is the difference between the Electricity production(% of total) in OECD members and Electricity production(% of total) in Jordan?
Keep it short and to the point. 14.24. In the year 1998, what is the difference between the Electricity production(% of total) of Bolivia and Electricity production(% of total) of El Salvador?
Provide a short and direct response. 0.46. In the year 1998, what is the difference between the Electricity production(% of total) in Bolivia and Electricity production(% of total) in Jordan?
Offer a very short reply. 41.75. In the year 1998, what is the difference between the Electricity production(% of total) of El Salvador and Electricity production(% of total) of Jordan?
Make the answer very short. 41.29. In the year 1999, what is the difference between the Electricity production(% of total) in OECD members and Electricity production(% of total) in Bolivia?
Offer a terse response. -31.91. In the year 1999, what is the difference between the Electricity production(% of total) in OECD members and Electricity production(% of total) in El Salvador?
Provide a succinct answer. -33.86. In the year 1999, what is the difference between the Electricity production(% of total) in OECD members and Electricity production(% of total) in Jordan?
Provide a succinct answer. 13.91. In the year 1999, what is the difference between the Electricity production(% of total) of Bolivia and Electricity production(% of total) of El Salvador?
Offer a very short reply. -1.95. In the year 1999, what is the difference between the Electricity production(% of total) of Bolivia and Electricity production(% of total) of Jordan?
Offer a terse response. 45.82. In the year 1999, what is the difference between the Electricity production(% of total) of El Salvador and Electricity production(% of total) of Jordan?
Provide a short and direct response. 47.77. In the year 2000, what is the difference between the Electricity production(% of total) of OECD members and Electricity production(% of total) of Bolivia?
Offer a very short reply. -36.34. In the year 2000, what is the difference between the Electricity production(% of total) of OECD members and Electricity production(% of total) of El Salvador?
Your response must be concise. -21.01. In the year 2000, what is the difference between the Electricity production(% of total) in OECD members and Electricity production(% of total) in Jordan?
Ensure brevity in your answer.  13.26. In the year 2000, what is the difference between the Electricity production(% of total) in Bolivia and Electricity production(% of total) in El Salvador?
Keep it short and to the point. 15.33. In the year 2000, what is the difference between the Electricity production(% of total) in Bolivia and Electricity production(% of total) in Jordan?
Your response must be concise. 49.6. In the year 2000, what is the difference between the Electricity production(% of total) in El Salvador and Electricity production(% of total) in Jordan?
Offer a terse response. 34.27. In the year 2001, what is the difference between the Electricity production(% of total) of OECD members and Electricity production(% of total) of Bolivia?
Your response must be concise. -40.57. In the year 2001, what is the difference between the Electricity production(% of total) of OECD members and Electricity production(% of total) of El Salvador?
Your answer should be very brief. -16.69. In the year 2001, what is the difference between the Electricity production(% of total) of OECD members and Electricity production(% of total) of Jordan?
Offer a very short reply. 12.35. In the year 2001, what is the difference between the Electricity production(% of total) of Bolivia and Electricity production(% of total) of El Salvador?
Offer a terse response. 23.88. In the year 2001, what is the difference between the Electricity production(% of total) in Bolivia and Electricity production(% of total) in Jordan?
Your answer should be compact. 52.92. In the year 2001, what is the difference between the Electricity production(% of total) of El Salvador and Electricity production(% of total) of Jordan?
Ensure brevity in your answer.  29.04. In the year 2002, what is the difference between the Electricity production(% of total) of OECD members and Electricity production(% of total) of Bolivia?
Keep it short and to the point. -39.62. In the year 2002, what is the difference between the Electricity production(% of total) of OECD members and Electricity production(% of total) of El Salvador?
Offer a terse response. -14.42. In the year 2002, what is the difference between the Electricity production(% of total) in OECD members and Electricity production(% of total) in Jordan?
Your response must be concise. 12.38. In the year 2002, what is the difference between the Electricity production(% of total) of Bolivia and Electricity production(% of total) of El Salvador?
Give a very brief answer. 25.2. In the year 2002, what is the difference between the Electricity production(% of total) in Bolivia and Electricity production(% of total) in Jordan?
Your answer should be compact. 52. In the year 2002, what is the difference between the Electricity production(% of total) in El Salvador and Electricity production(% of total) in Jordan?
Provide a succinct answer. 26.8. In the year 2003, what is the difference between the Electricity production(% of total) of OECD members and Electricity production(% of total) of Bolivia?
Offer a terse response. -33.2. In the year 2003, what is the difference between the Electricity production(% of total) of OECD members and Electricity production(% of total) of El Salvador?
Give a very brief answer. -20.47. In the year 2003, what is the difference between the Electricity production(% of total) in OECD members and Electricity production(% of total) in Jordan?
Give a very brief answer. 12.15. In the year 2003, what is the difference between the Electricity production(% of total) in Bolivia and Electricity production(% of total) in El Salvador?
Make the answer very short. 12.73. In the year 2003, what is the difference between the Electricity production(% of total) of Bolivia and Electricity production(% of total) of Jordan?
Your answer should be very brief. 45.36. In the year 2003, what is the difference between the Electricity production(% of total) in El Salvador and Electricity production(% of total) in Jordan?
Your answer should be very brief. 32.62. What is the ratio of the Electricity production(% of total) in OECD members in 1997 to that in 1998?
Provide a succinct answer. 1.06. What is the ratio of the Electricity production(% of total) of Bolivia in 1997 to that in 1998?
Keep it short and to the point. 1.07. What is the ratio of the Electricity production(% of total) of El Salvador in 1997 to that in 1998?
Offer a very short reply. 0.96. What is the ratio of the Electricity production(% of total) in Jordan in 1997 to that in 1998?
Make the answer very short. 1.41. What is the ratio of the Electricity production(% of total) of OECD members in 1997 to that in 1999?
Keep it short and to the point. 1.08. What is the ratio of the Electricity production(% of total) of Bolivia in 1997 to that in 1999?
Offer a terse response. 0.98. What is the ratio of the Electricity production(% of total) in El Salvador in 1997 to that in 1999?
Offer a terse response. 0.83. What is the ratio of the Electricity production(% of total) of Jordan in 1997 to that in 1999?
Offer a very short reply. 1.37. What is the ratio of the Electricity production(% of total) in OECD members in 1997 to that in 2000?
Your answer should be compact. 1.1. What is the ratio of the Electricity production(% of total) of Bolivia in 1997 to that in 2000?
Your response must be concise. 0.9. What is the ratio of the Electricity production(% of total) of El Salvador in 1997 to that in 2000?
Ensure brevity in your answer.  1.15. What is the ratio of the Electricity production(% of total) of Jordan in 1997 to that in 2000?
Keep it short and to the point. 0.51. What is the ratio of the Electricity production(% of total) of OECD members in 1997 to that in 2001?
Keep it short and to the point. 1.18. What is the ratio of the Electricity production(% of total) in Bolivia in 1997 to that in 2001?
Make the answer very short. 0.84. What is the ratio of the Electricity production(% of total) of El Salvador in 1997 to that in 2001?
Provide a succinct answer. 1.35. What is the ratio of the Electricity production(% of total) of Jordan in 1997 to that in 2001?
Keep it short and to the point. 0.48. What is the ratio of the Electricity production(% of total) in OECD members in 1997 to that in 2002?
Keep it short and to the point. 1.17. What is the ratio of the Electricity production(% of total) of Bolivia in 1997 to that in 2002?
Keep it short and to the point. 0.86. What is the ratio of the Electricity production(% of total) of El Salvador in 1997 to that in 2002?
Provide a short and direct response. 1.45. What is the ratio of the Electricity production(% of total) of Jordan in 1997 to that in 2002?
Offer a terse response. 0.42. What is the ratio of the Electricity production(% of total) in OECD members in 1997 to that in 2003?
Make the answer very short. 1.2. What is the ratio of the Electricity production(% of total) in Bolivia in 1997 to that in 2003?
Keep it short and to the point. 0.98. What is the ratio of the Electricity production(% of total) of El Salvador in 1997 to that in 2003?
Your answer should be very brief. 1.2. What is the ratio of the Electricity production(% of total) of Jordan in 1997 to that in 2003?
Make the answer very short. 0.53. What is the ratio of the Electricity production(% of total) of OECD members in 1998 to that in 1999?
Your answer should be very brief. 1.02. What is the ratio of the Electricity production(% of total) of Bolivia in 1998 to that in 1999?
Provide a succinct answer. 0.91. What is the ratio of the Electricity production(% of total) in El Salvador in 1998 to that in 1999?
Provide a short and direct response. 0.86. What is the ratio of the Electricity production(% of total) in Jordan in 1998 to that in 1999?
Your response must be concise. 0.97. What is the ratio of the Electricity production(% of total) of OECD members in 1998 to that in 2000?
Your answer should be compact. 1.05. What is the ratio of the Electricity production(% of total) of Bolivia in 1998 to that in 2000?
Make the answer very short. 0.84. What is the ratio of the Electricity production(% of total) in El Salvador in 1998 to that in 2000?
Your answer should be very brief. 1.19. What is the ratio of the Electricity production(% of total) of Jordan in 1998 to that in 2000?
Provide a short and direct response. 0.36. What is the ratio of the Electricity production(% of total) in OECD members in 1998 to that in 2001?
Provide a succinct answer. 1.12. What is the ratio of the Electricity production(% of total) of Bolivia in 1998 to that in 2001?
Give a very brief answer. 0.78. What is the ratio of the Electricity production(% of total) of El Salvador in 1998 to that in 2001?
Your answer should be very brief. 1.4. What is the ratio of the Electricity production(% of total) in Jordan in 1998 to that in 2001?
Your response must be concise. 0.34. What is the ratio of the Electricity production(% of total) in OECD members in 1998 to that in 2002?
Ensure brevity in your answer.  1.11. What is the ratio of the Electricity production(% of total) in Bolivia in 1998 to that in 2002?
Make the answer very short. 0.8. What is the ratio of the Electricity production(% of total) of El Salvador in 1998 to that in 2002?
Give a very brief answer. 1.51. What is the ratio of the Electricity production(% of total) in Jordan in 1998 to that in 2002?
Offer a terse response. 0.3. What is the ratio of the Electricity production(% of total) of OECD members in 1998 to that in 2003?
Offer a very short reply. 1.14. What is the ratio of the Electricity production(% of total) of Bolivia in 1998 to that in 2003?
Make the answer very short. 0.91. What is the ratio of the Electricity production(% of total) in El Salvador in 1998 to that in 2003?
Offer a terse response. 1.25. What is the ratio of the Electricity production(% of total) of Jordan in 1998 to that in 2003?
Offer a very short reply. 0.38. What is the ratio of the Electricity production(% of total) in OECD members in 1999 to that in 2000?
Your answer should be very brief. 1.02. What is the ratio of the Electricity production(% of total) of Bolivia in 1999 to that in 2000?
Provide a short and direct response. 0.92. What is the ratio of the Electricity production(% of total) of El Salvador in 1999 to that in 2000?
Give a very brief answer. 1.38. What is the ratio of the Electricity production(% of total) in Jordan in 1999 to that in 2000?
Offer a very short reply. 0.37. What is the ratio of the Electricity production(% of total) in OECD members in 1999 to that in 2001?
Keep it short and to the point. 1.09. What is the ratio of the Electricity production(% of total) in Bolivia in 1999 to that in 2001?
Provide a succinct answer. 0.86. What is the ratio of the Electricity production(% of total) in El Salvador in 1999 to that in 2001?
Your answer should be compact. 1.62. What is the ratio of the Electricity production(% of total) of Jordan in 1999 to that in 2001?
Your answer should be compact. 0.35. What is the ratio of the Electricity production(% of total) of OECD members in 1999 to that in 2002?
Provide a succinct answer. 1.08. What is the ratio of the Electricity production(% of total) in Bolivia in 1999 to that in 2002?
Offer a very short reply. 0.87. What is the ratio of the Electricity production(% of total) in El Salvador in 1999 to that in 2002?
Your response must be concise. 1.75. What is the ratio of the Electricity production(% of total) of Jordan in 1999 to that in 2002?
Offer a very short reply. 0.3. What is the ratio of the Electricity production(% of total) in OECD members in 1999 to that in 2003?
Your answer should be compact. 1.11. What is the ratio of the Electricity production(% of total) in El Salvador in 1999 to that in 2003?
Keep it short and to the point. 1.45. What is the ratio of the Electricity production(% of total) in Jordan in 1999 to that in 2003?
Provide a short and direct response. 0.39. What is the ratio of the Electricity production(% of total) of OECD members in 2000 to that in 2001?
Ensure brevity in your answer.  1.07. What is the ratio of the Electricity production(% of total) in Bolivia in 2000 to that in 2001?
Provide a short and direct response. 0.94. What is the ratio of the Electricity production(% of total) in El Salvador in 2000 to that in 2001?
Make the answer very short. 1.18. What is the ratio of the Electricity production(% of total) in Jordan in 2000 to that in 2001?
Make the answer very short. 0.93. What is the ratio of the Electricity production(% of total) of OECD members in 2000 to that in 2002?
Provide a short and direct response. 1.06. What is the ratio of the Electricity production(% of total) in Bolivia in 2000 to that in 2002?
Your answer should be compact. 0.95. What is the ratio of the Electricity production(% of total) of El Salvador in 2000 to that in 2002?
Offer a terse response. 1.27. What is the ratio of the Electricity production(% of total) in Jordan in 2000 to that in 2002?
Make the answer very short. 0.81. What is the ratio of the Electricity production(% of total) of OECD members in 2000 to that in 2003?
Your answer should be compact. 1.09. What is the ratio of the Electricity production(% of total) in Bolivia in 2000 to that in 2003?
Offer a very short reply. 1.09. What is the ratio of the Electricity production(% of total) of Jordan in 2000 to that in 2003?
Your response must be concise. 1.03. What is the ratio of the Electricity production(% of total) of Bolivia in 2001 to that in 2002?
Offer a very short reply. 1.02. What is the ratio of the Electricity production(% of total) of El Salvador in 2001 to that in 2002?
Your answer should be compact. 1.08. What is the ratio of the Electricity production(% of total) of Jordan in 2001 to that in 2002?
Your response must be concise. 0.87. What is the ratio of the Electricity production(% of total) of OECD members in 2001 to that in 2003?
Make the answer very short. 1.02. What is the ratio of the Electricity production(% of total) of Bolivia in 2001 to that in 2003?
Your answer should be compact. 1.17. What is the ratio of the Electricity production(% of total) of El Salvador in 2001 to that in 2003?
Your answer should be very brief. 0.89. What is the ratio of the Electricity production(% of total) in Jordan in 2001 to that in 2003?
Your answer should be compact. 1.11. What is the ratio of the Electricity production(% of total) in OECD members in 2002 to that in 2003?
Provide a short and direct response. 1.03. What is the ratio of the Electricity production(% of total) of Bolivia in 2002 to that in 2003?
Your answer should be compact. 1.15. What is the ratio of the Electricity production(% of total) of El Salvador in 2002 to that in 2003?
Make the answer very short. 0.83. What is the ratio of the Electricity production(% of total) in Jordan in 2002 to that in 2003?
Provide a short and direct response. 1.27. What is the difference between the highest and the second highest Electricity production(% of total) of OECD members?
Provide a succinct answer. 0.8. What is the difference between the highest and the second highest Electricity production(% of total) in Bolivia?
Provide a short and direct response. 0.84. What is the difference between the highest and the second highest Electricity production(% of total) of El Salvador?
Ensure brevity in your answer.  6.48. What is the difference between the highest and the second highest Electricity production(% of total) in Jordan?
Offer a terse response. 0.08. What is the difference between the highest and the lowest Electricity production(% of total) in OECD members?
Give a very brief answer. 2.57. What is the difference between the highest and the lowest Electricity production(% of total) in Bolivia?
Offer a terse response. 11.55. What is the difference between the highest and the lowest Electricity production(% of total) in El Salvador?
Your answer should be very brief. 20.51. What is the difference between the highest and the lowest Electricity production(% of total) of Jordan?
Provide a short and direct response. 0.46. 